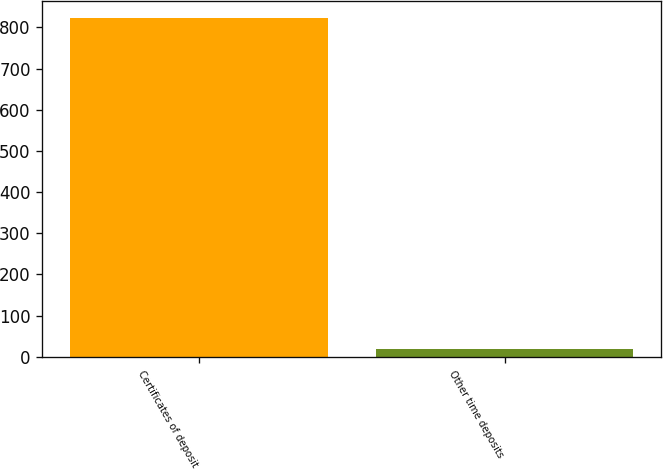<chart> <loc_0><loc_0><loc_500><loc_500><bar_chart><fcel>Certificates of deposit<fcel>Other time deposits<nl><fcel>823<fcel>19<nl></chart> 